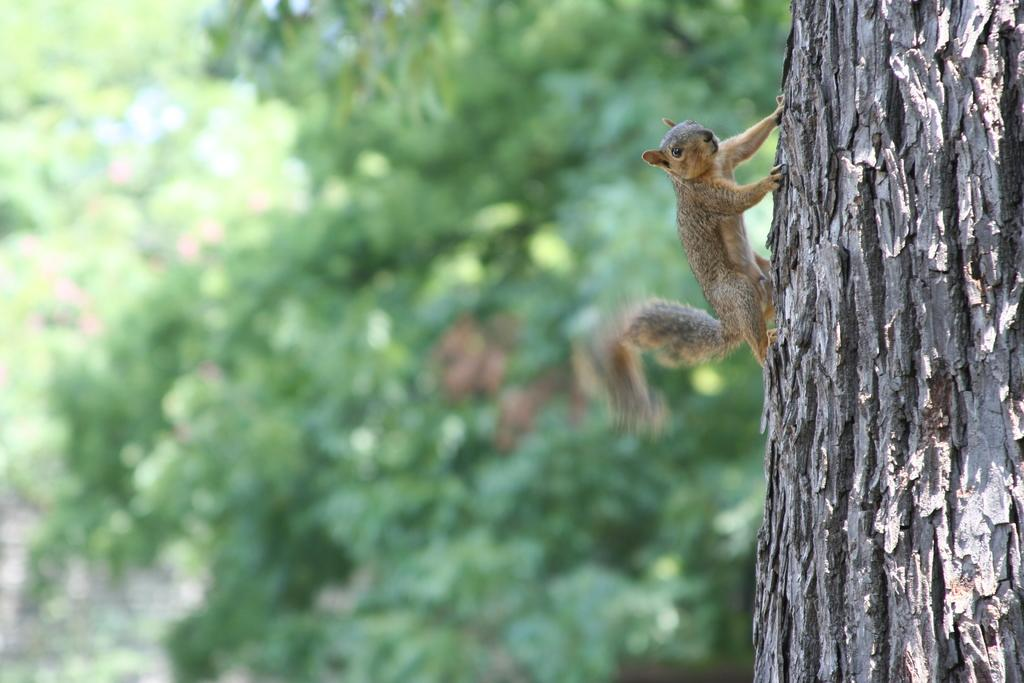What animal is present in the image? There is a squirrel in the image. Where is the squirrel located? The squirrel is on a branch of a tree. What is the color of the squirrel? The squirrel is brown in color. What can be seen in the background of the image? There are trees in the background of the image, but they are blurry. What type of trousers is the squirrel wearing in the image? Squirrels do not wear trousers, so this detail cannot be found in the image. 